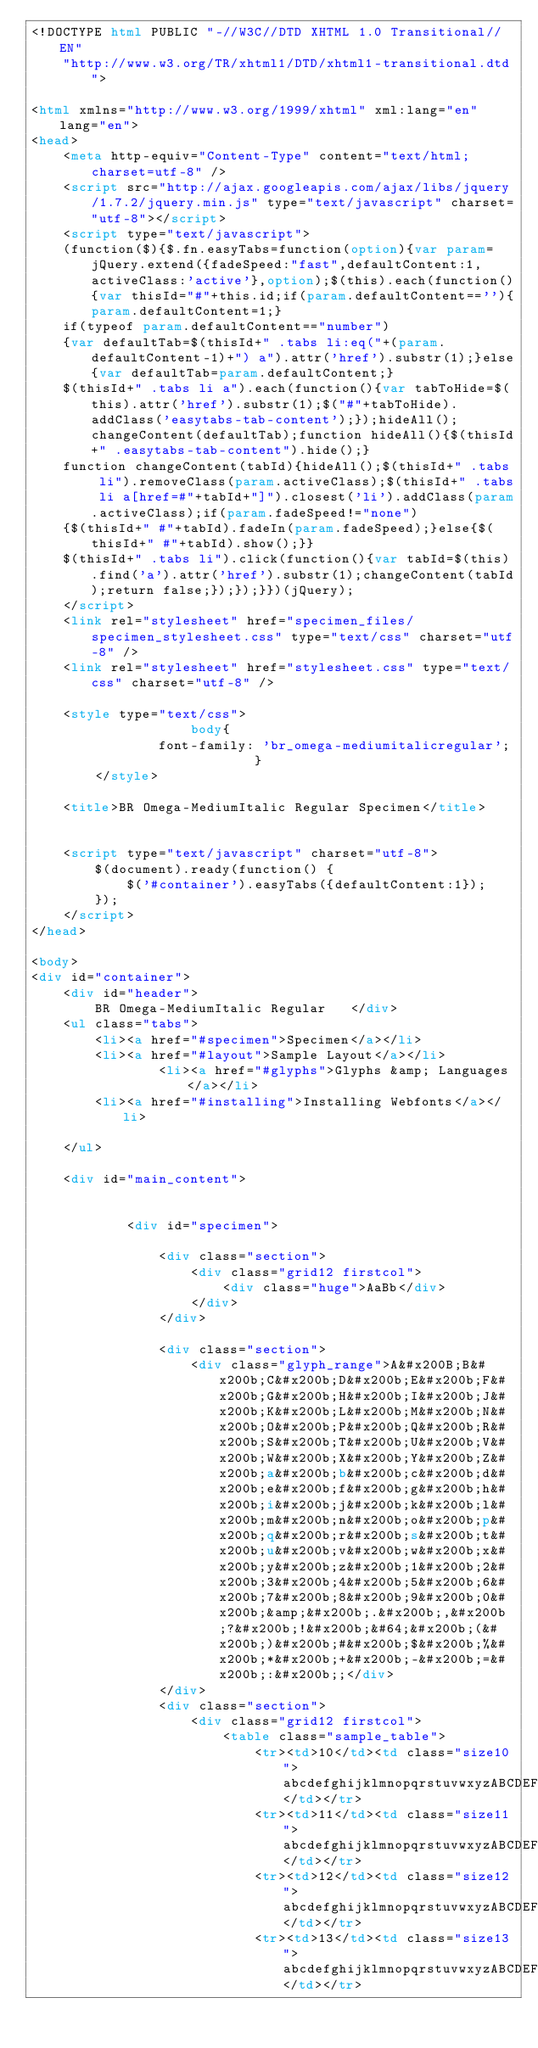<code> <loc_0><loc_0><loc_500><loc_500><_HTML_><!DOCTYPE html PUBLIC "-//W3C//DTD XHTML 1.0 Transitional//EN"
	"http://www.w3.org/TR/xhtml1/DTD/xhtml1-transitional.dtd">

<html xmlns="http://www.w3.org/1999/xhtml" xml:lang="en" lang="en">
<head>
	<meta http-equiv="Content-Type" content="text/html; charset=utf-8" />
	<script src="http://ajax.googleapis.com/ajax/libs/jquery/1.7.2/jquery.min.js" type="text/javascript" charset="utf-8"></script>
	<script type="text/javascript">
	(function($){$.fn.easyTabs=function(option){var param=jQuery.extend({fadeSpeed:"fast",defaultContent:1,activeClass:'active'},option);$(this).each(function(){var thisId="#"+this.id;if(param.defaultContent==''){param.defaultContent=1;}
	if(typeof param.defaultContent=="number")
	{var defaultTab=$(thisId+" .tabs li:eq("+(param.defaultContent-1)+") a").attr('href').substr(1);}else{var defaultTab=param.defaultContent;}
	$(thisId+" .tabs li a").each(function(){var tabToHide=$(this).attr('href').substr(1);$("#"+tabToHide).addClass('easytabs-tab-content');});hideAll();changeContent(defaultTab);function hideAll(){$(thisId+" .easytabs-tab-content").hide();}
	function changeContent(tabId){hideAll();$(thisId+" .tabs li").removeClass(param.activeClass);$(thisId+" .tabs li a[href=#"+tabId+"]").closest('li').addClass(param.activeClass);if(param.fadeSpeed!="none")
	{$(thisId+" #"+tabId).fadeIn(param.fadeSpeed);}else{$(thisId+" #"+tabId).show();}}
	$(thisId+" .tabs li").click(function(){var tabId=$(this).find('a').attr('href').substr(1);changeContent(tabId);return false;});});}})(jQuery);
	</script>
	<link rel="stylesheet" href="specimen_files/specimen_stylesheet.css" type="text/css" charset="utf-8" />
	<link rel="stylesheet" href="stylesheet.css" type="text/css" charset="utf-8" />

	<style type="text/css">
					body{
				font-family: 'br_omega-mediumitalicregular';
							}
		</style>

	<title>BR Omega-MediumItalic Regular Specimen</title>
	
	
	<script type="text/javascript" charset="utf-8">
		$(document).ready(function() {
			$('#container').easyTabs({defaultContent:1});
		});
	</script>
</head>

<body>
<div id="container">
	<div id="header">
		BR Omega-MediumItalic Regular	</div>
	<ul class="tabs">
		<li><a href="#specimen">Specimen</a></li>
		<li><a href="#layout">Sample Layout</a></li>
				<li><a href="#glyphs">Glyphs &amp; Languages</a></li>
		<li><a href="#installing">Installing Webfonts</a></li>
		
	</ul>
	
	<div id="main_content">

		
			<div id="specimen">
		
				<div class="section">
					<div class="grid12 firstcol">
						<div class="huge">AaBb</div>
					</div>
				</div>
		
				<div class="section">
					<div class="glyph_range">A&#x200B;B&#x200b;C&#x200b;D&#x200b;E&#x200b;F&#x200b;G&#x200b;H&#x200b;I&#x200b;J&#x200b;K&#x200b;L&#x200b;M&#x200b;N&#x200b;O&#x200b;P&#x200b;Q&#x200b;R&#x200b;S&#x200b;T&#x200b;U&#x200b;V&#x200b;W&#x200b;X&#x200b;Y&#x200b;Z&#x200b;a&#x200b;b&#x200b;c&#x200b;d&#x200b;e&#x200b;f&#x200b;g&#x200b;h&#x200b;i&#x200b;j&#x200b;k&#x200b;l&#x200b;m&#x200b;n&#x200b;o&#x200b;p&#x200b;q&#x200b;r&#x200b;s&#x200b;t&#x200b;u&#x200b;v&#x200b;w&#x200b;x&#x200b;y&#x200b;z&#x200b;1&#x200b;2&#x200b;3&#x200b;4&#x200b;5&#x200b;6&#x200b;7&#x200b;8&#x200b;9&#x200b;0&#x200b;&amp;&#x200b;.&#x200b;,&#x200b;?&#x200b;!&#x200b;&#64;&#x200b;(&#x200b;)&#x200b;#&#x200b;$&#x200b;%&#x200b;*&#x200b;+&#x200b;-&#x200b;=&#x200b;:&#x200b;;</div>
				</div>
				<div class="section">
					<div class="grid12 firstcol">
						<table class="sample_table">
							<tr><td>10</td><td class="size10">abcdefghijklmnopqrstuvwxyzABCDEFGHIJKLMNOPQRSTUVWXYZ0123456789abcdefghijklmnopqrstuvwxyzABCDEFGHIJKLMNOPQRSTUVWXYZ0123456789abcdefghijklmnopqrstuvwxyzABCDEFGHIJKLMNOPQRSTUVWXYZ</td></tr>
							<tr><td>11</td><td class="size11">abcdefghijklmnopqrstuvwxyzABCDEFGHIJKLMNOPQRSTUVWXYZ0123456789abcdefghijklmnopqrstuvwxyzABCDEFGHIJKLMNOPQRSTUVWXYZ0123456789abcdefghijklmnopqrstuvwxyzABCDEFGHIJKLMNOPQRSTUVWXYZ</td></tr>
							<tr><td>12</td><td class="size12">abcdefghijklmnopqrstuvwxyzABCDEFGHIJKLMNOPQRSTUVWXYZ0123456789abcdefghijklmnopqrstuvwxyzABCDEFGHIJKLMNOPQRSTUVWXYZ0123456789abcdefghijklmnopqrstuvwxyzABCDEFGHIJKLMNOPQRSTUVWXYZ</td></tr>
							<tr><td>13</td><td class="size13">abcdefghijklmnopqrstuvwxyzABCDEFGHIJKLMNOPQRSTUVWXYZ0123456789abcdefghijklmnopqrstuvwxyzABCDEFGHIJKLMNOPQRSTUVWXYZ0123456789abcdefghijklmnopqrstuvwxyzABCDEFGHIJKLMNOPQRSTUVWXYZ</td></tr></code> 